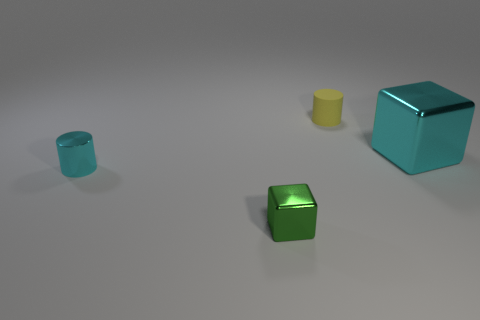Is there a yellow cylinder that has the same size as the green thing?
Make the answer very short. Yes. Is the shape of the small green thing the same as the cyan metallic object that is on the left side of the rubber cylinder?
Give a very brief answer. No. There is a yellow cylinder that is behind the big cyan cube; is it the same size as the cyan shiny thing to the left of the large cyan metal object?
Your response must be concise. Yes. How many other objects are there of the same shape as the large object?
Offer a terse response. 1. There is a block in front of the shiny thing that is right of the green shiny thing; what is its material?
Provide a succinct answer. Metal. How many matte objects are big red balls or large cyan blocks?
Ensure brevity in your answer.  0. Are there any other things that have the same material as the small green thing?
Make the answer very short. Yes. Is there a cyan object that is in front of the tiny yellow cylinder behind the cyan cylinder?
Provide a succinct answer. Yes. What number of objects are tiny objects right of the green object or metal things left of the tiny green thing?
Ensure brevity in your answer.  2. Is there any other thing of the same color as the rubber object?
Your answer should be compact. No. 